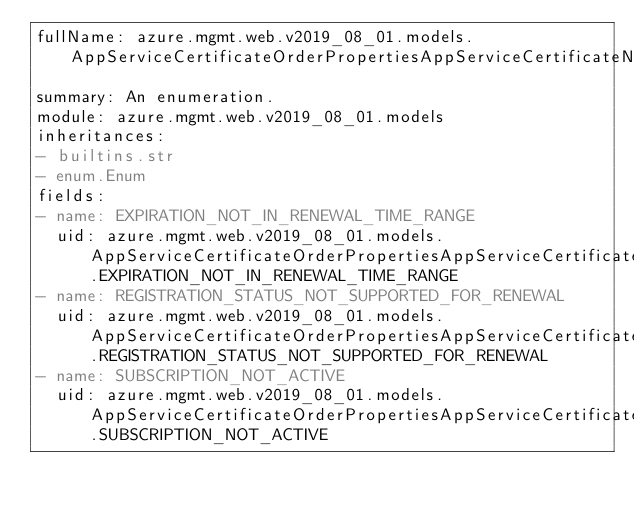Convert code to text. <code><loc_0><loc_0><loc_500><loc_500><_YAML_>fullName: azure.mgmt.web.v2019_08_01.models.AppServiceCertificateOrderPropertiesAppServiceCertificateNotRenewableReasonsItem
summary: An enumeration.
module: azure.mgmt.web.v2019_08_01.models
inheritances:
- builtins.str
- enum.Enum
fields:
- name: EXPIRATION_NOT_IN_RENEWAL_TIME_RANGE
  uid: azure.mgmt.web.v2019_08_01.models.AppServiceCertificateOrderPropertiesAppServiceCertificateNotRenewableReasonsItem.EXPIRATION_NOT_IN_RENEWAL_TIME_RANGE
- name: REGISTRATION_STATUS_NOT_SUPPORTED_FOR_RENEWAL
  uid: azure.mgmt.web.v2019_08_01.models.AppServiceCertificateOrderPropertiesAppServiceCertificateNotRenewableReasonsItem.REGISTRATION_STATUS_NOT_SUPPORTED_FOR_RENEWAL
- name: SUBSCRIPTION_NOT_ACTIVE
  uid: azure.mgmt.web.v2019_08_01.models.AppServiceCertificateOrderPropertiesAppServiceCertificateNotRenewableReasonsItem.SUBSCRIPTION_NOT_ACTIVE
</code> 